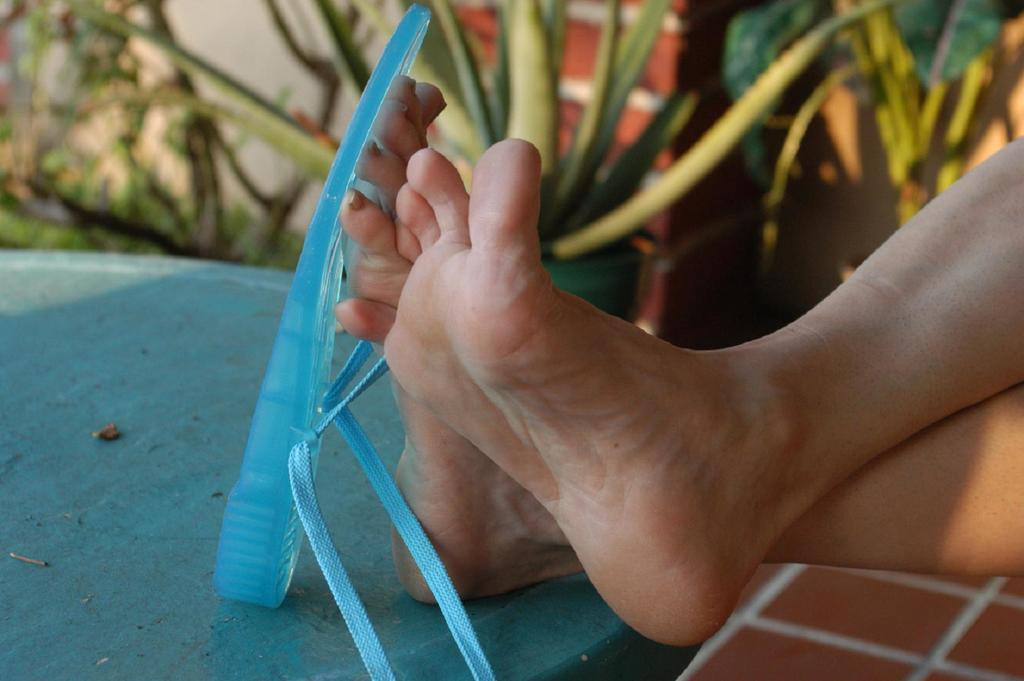What body parts can be seen in the image? There are legs visible in the image. What type of footwear is present in the image? There are slippers in the image. What can be seen in the background of the image? There are plants in the background of the image. How would you describe the background of the image? The background is blurred. What type of string is being used to hold the plants in the image? There is no string visible in the image, and the plants are not being held by any visible means. 